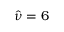Convert formula to latex. <formula><loc_0><loc_0><loc_500><loc_500>\hat { \nu } = 6</formula> 